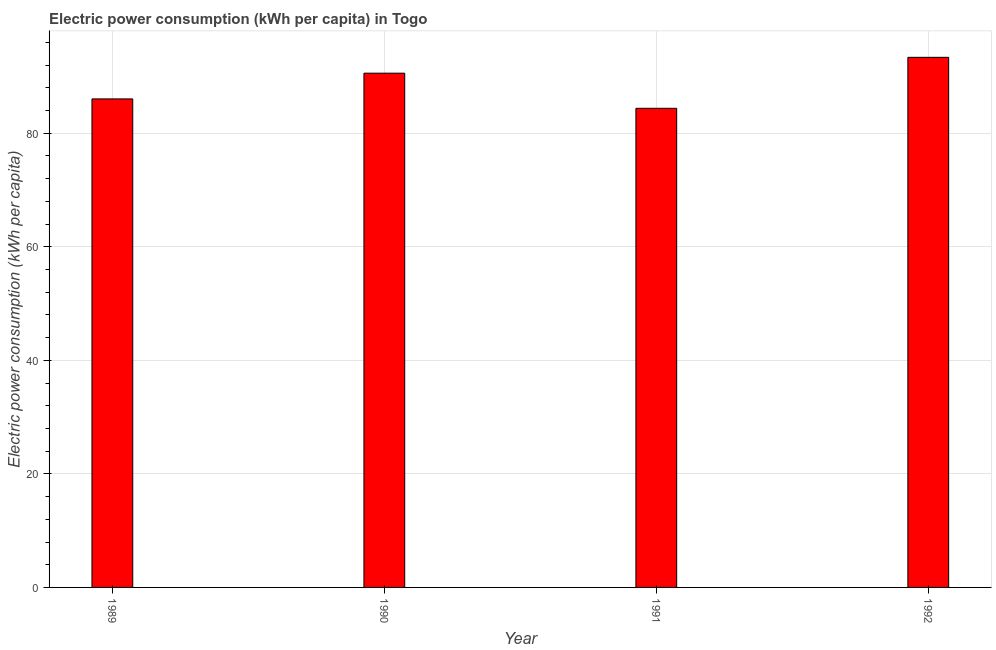Does the graph contain grids?
Provide a short and direct response. Yes. What is the title of the graph?
Provide a succinct answer. Electric power consumption (kWh per capita) in Togo. What is the label or title of the X-axis?
Provide a succinct answer. Year. What is the label or title of the Y-axis?
Your response must be concise. Electric power consumption (kWh per capita). What is the electric power consumption in 1990?
Ensure brevity in your answer.  90.57. Across all years, what is the maximum electric power consumption?
Keep it short and to the point. 93.37. Across all years, what is the minimum electric power consumption?
Provide a succinct answer. 84.39. In which year was the electric power consumption maximum?
Your answer should be very brief. 1992. In which year was the electric power consumption minimum?
Make the answer very short. 1991. What is the sum of the electric power consumption?
Provide a short and direct response. 354.37. What is the difference between the electric power consumption in 1990 and 1992?
Your answer should be very brief. -2.79. What is the average electric power consumption per year?
Your response must be concise. 88.59. What is the median electric power consumption?
Offer a terse response. 88.31. What is the ratio of the electric power consumption in 1989 to that in 1991?
Make the answer very short. 1.02. Is the difference between the electric power consumption in 1989 and 1992 greater than the difference between any two years?
Your answer should be very brief. No. What is the difference between the highest and the second highest electric power consumption?
Keep it short and to the point. 2.79. Is the sum of the electric power consumption in 1990 and 1992 greater than the maximum electric power consumption across all years?
Provide a succinct answer. Yes. What is the difference between the highest and the lowest electric power consumption?
Offer a terse response. 8.98. In how many years, is the electric power consumption greater than the average electric power consumption taken over all years?
Offer a terse response. 2. Are all the bars in the graph horizontal?
Your response must be concise. No. How many years are there in the graph?
Keep it short and to the point. 4. What is the difference between two consecutive major ticks on the Y-axis?
Offer a terse response. 20. Are the values on the major ticks of Y-axis written in scientific E-notation?
Your response must be concise. No. What is the Electric power consumption (kWh per capita) of 1989?
Offer a very short reply. 86.04. What is the Electric power consumption (kWh per capita) of 1990?
Provide a succinct answer. 90.57. What is the Electric power consumption (kWh per capita) of 1991?
Offer a terse response. 84.39. What is the Electric power consumption (kWh per capita) in 1992?
Offer a very short reply. 93.37. What is the difference between the Electric power consumption (kWh per capita) in 1989 and 1990?
Offer a terse response. -4.53. What is the difference between the Electric power consumption (kWh per capita) in 1989 and 1991?
Give a very brief answer. 1.65. What is the difference between the Electric power consumption (kWh per capita) in 1989 and 1992?
Offer a terse response. -7.32. What is the difference between the Electric power consumption (kWh per capita) in 1990 and 1991?
Your response must be concise. 6.19. What is the difference between the Electric power consumption (kWh per capita) in 1990 and 1992?
Offer a terse response. -2.79. What is the difference between the Electric power consumption (kWh per capita) in 1991 and 1992?
Give a very brief answer. -8.98. What is the ratio of the Electric power consumption (kWh per capita) in 1989 to that in 1990?
Your response must be concise. 0.95. What is the ratio of the Electric power consumption (kWh per capita) in 1989 to that in 1991?
Give a very brief answer. 1.02. What is the ratio of the Electric power consumption (kWh per capita) in 1989 to that in 1992?
Provide a short and direct response. 0.92. What is the ratio of the Electric power consumption (kWh per capita) in 1990 to that in 1991?
Offer a very short reply. 1.07. What is the ratio of the Electric power consumption (kWh per capita) in 1991 to that in 1992?
Keep it short and to the point. 0.9. 